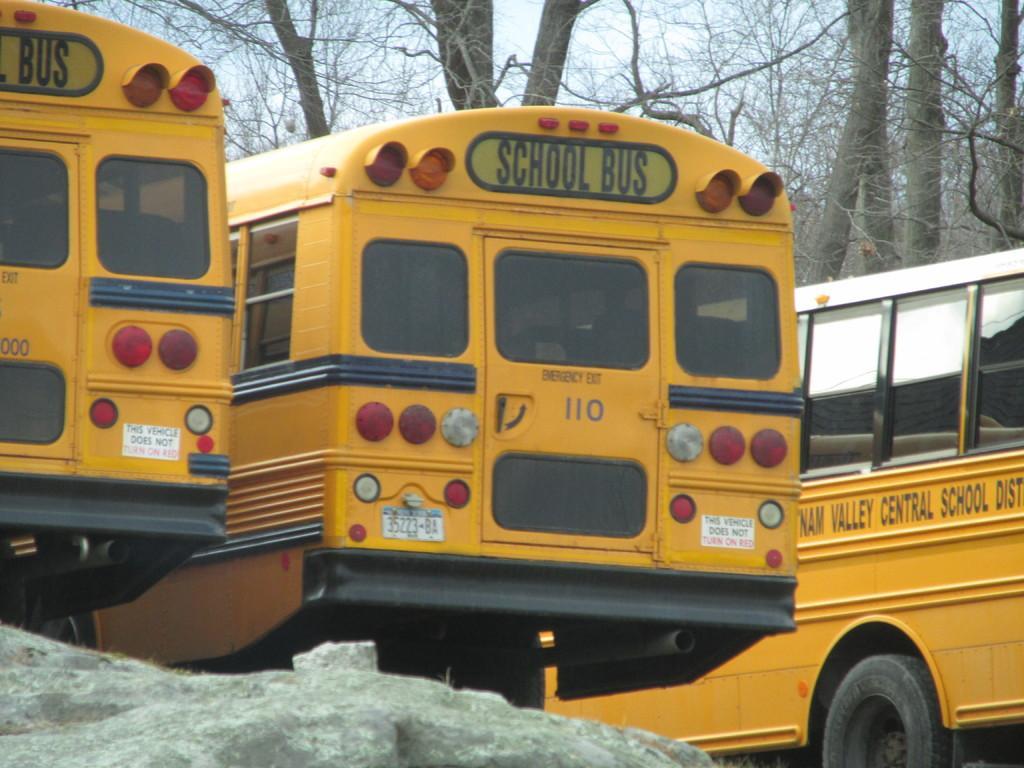Can you describe this image briefly? This is an outside view. Here I can see three yellow color school buses. There is some text on the bus which is on the right side. At the bottom there is a rock. In the background there are many trees. At the top I can see the sky. 